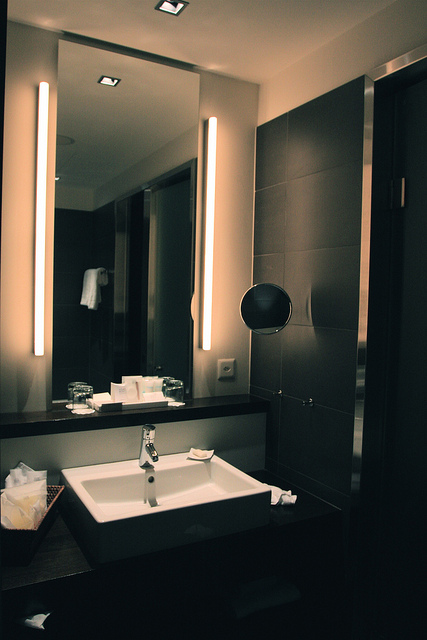How many vents can be spotted in the image, and where are they located? There are four vents in the image. One vent is towards the top left corner, another is at the top center, and two vents are positioned towards the top right side of the ceiling. 